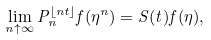Convert formula to latex. <formula><loc_0><loc_0><loc_500><loc_500>\lim _ { n \uparrow \infty } P _ { n } ^ { \lfloor n t \rfloor } f ( \eta ^ { n } ) = S ( t ) f ( \eta ) ,</formula> 